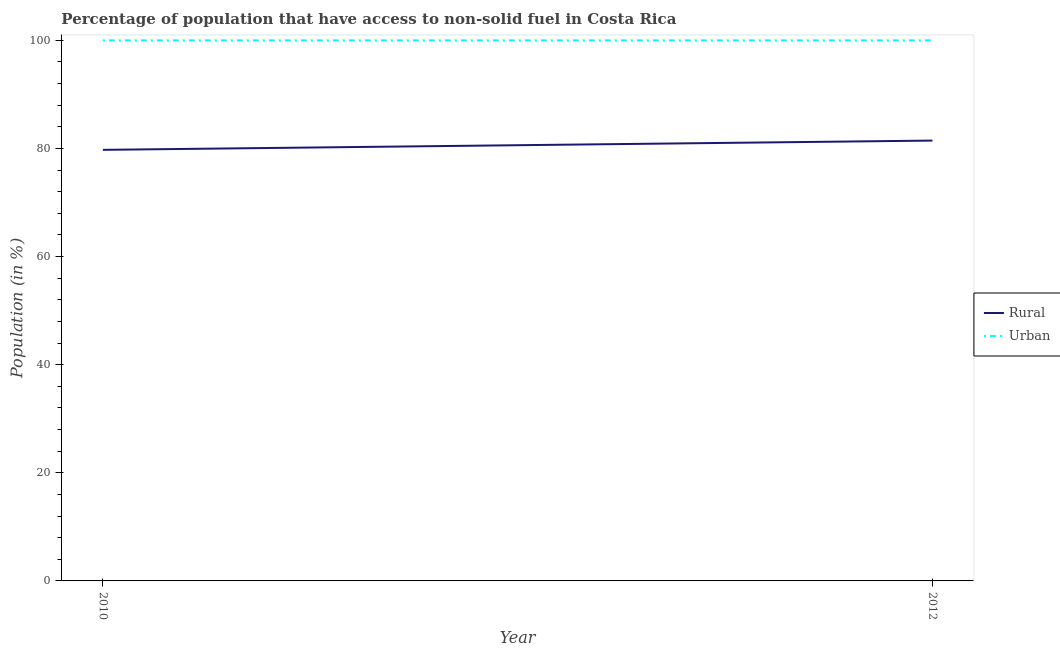How many different coloured lines are there?
Provide a succinct answer. 2. Does the line corresponding to urban population intersect with the line corresponding to rural population?
Offer a very short reply. No. What is the rural population in 2010?
Make the answer very short. 79.74. Across all years, what is the maximum urban population?
Offer a very short reply. 100. Across all years, what is the minimum urban population?
Keep it short and to the point. 100. In which year was the urban population maximum?
Provide a short and direct response. 2010. In which year was the rural population minimum?
Your response must be concise. 2010. What is the total rural population in the graph?
Provide a succinct answer. 161.2. What is the difference between the rural population in 2010 and that in 2012?
Ensure brevity in your answer.  -1.71. What is the difference between the urban population in 2012 and the rural population in 2010?
Ensure brevity in your answer.  20.26. In the year 2010, what is the difference between the urban population and rural population?
Keep it short and to the point. 20.26. What is the ratio of the urban population in 2010 to that in 2012?
Make the answer very short. 1. Is the urban population in 2010 less than that in 2012?
Offer a very short reply. No. Is the urban population strictly less than the rural population over the years?
Keep it short and to the point. No. How many years are there in the graph?
Ensure brevity in your answer.  2. What is the difference between two consecutive major ticks on the Y-axis?
Make the answer very short. 20. Does the graph contain any zero values?
Provide a succinct answer. No. How are the legend labels stacked?
Provide a short and direct response. Vertical. What is the title of the graph?
Give a very brief answer. Percentage of population that have access to non-solid fuel in Costa Rica. Does "Unregistered firms" appear as one of the legend labels in the graph?
Your answer should be very brief. No. What is the label or title of the X-axis?
Your answer should be compact. Year. What is the label or title of the Y-axis?
Your answer should be very brief. Population (in %). What is the Population (in %) of Rural in 2010?
Provide a succinct answer. 79.74. What is the Population (in %) of Urban in 2010?
Make the answer very short. 100. What is the Population (in %) of Rural in 2012?
Give a very brief answer. 81.46. Across all years, what is the maximum Population (in %) of Rural?
Your answer should be very brief. 81.46. Across all years, what is the minimum Population (in %) of Rural?
Give a very brief answer. 79.74. What is the total Population (in %) of Rural in the graph?
Keep it short and to the point. 161.2. What is the difference between the Population (in %) of Rural in 2010 and that in 2012?
Your answer should be very brief. -1.71. What is the difference between the Population (in %) of Urban in 2010 and that in 2012?
Give a very brief answer. 0. What is the difference between the Population (in %) of Rural in 2010 and the Population (in %) of Urban in 2012?
Give a very brief answer. -20.26. What is the average Population (in %) of Rural per year?
Your answer should be compact. 80.6. What is the average Population (in %) of Urban per year?
Offer a very short reply. 100. In the year 2010, what is the difference between the Population (in %) of Rural and Population (in %) of Urban?
Ensure brevity in your answer.  -20.26. In the year 2012, what is the difference between the Population (in %) of Rural and Population (in %) of Urban?
Make the answer very short. -18.54. What is the difference between the highest and the second highest Population (in %) in Rural?
Offer a terse response. 1.71. What is the difference between the highest and the second highest Population (in %) of Urban?
Your response must be concise. 0. What is the difference between the highest and the lowest Population (in %) in Rural?
Give a very brief answer. 1.71. What is the difference between the highest and the lowest Population (in %) of Urban?
Keep it short and to the point. 0. 